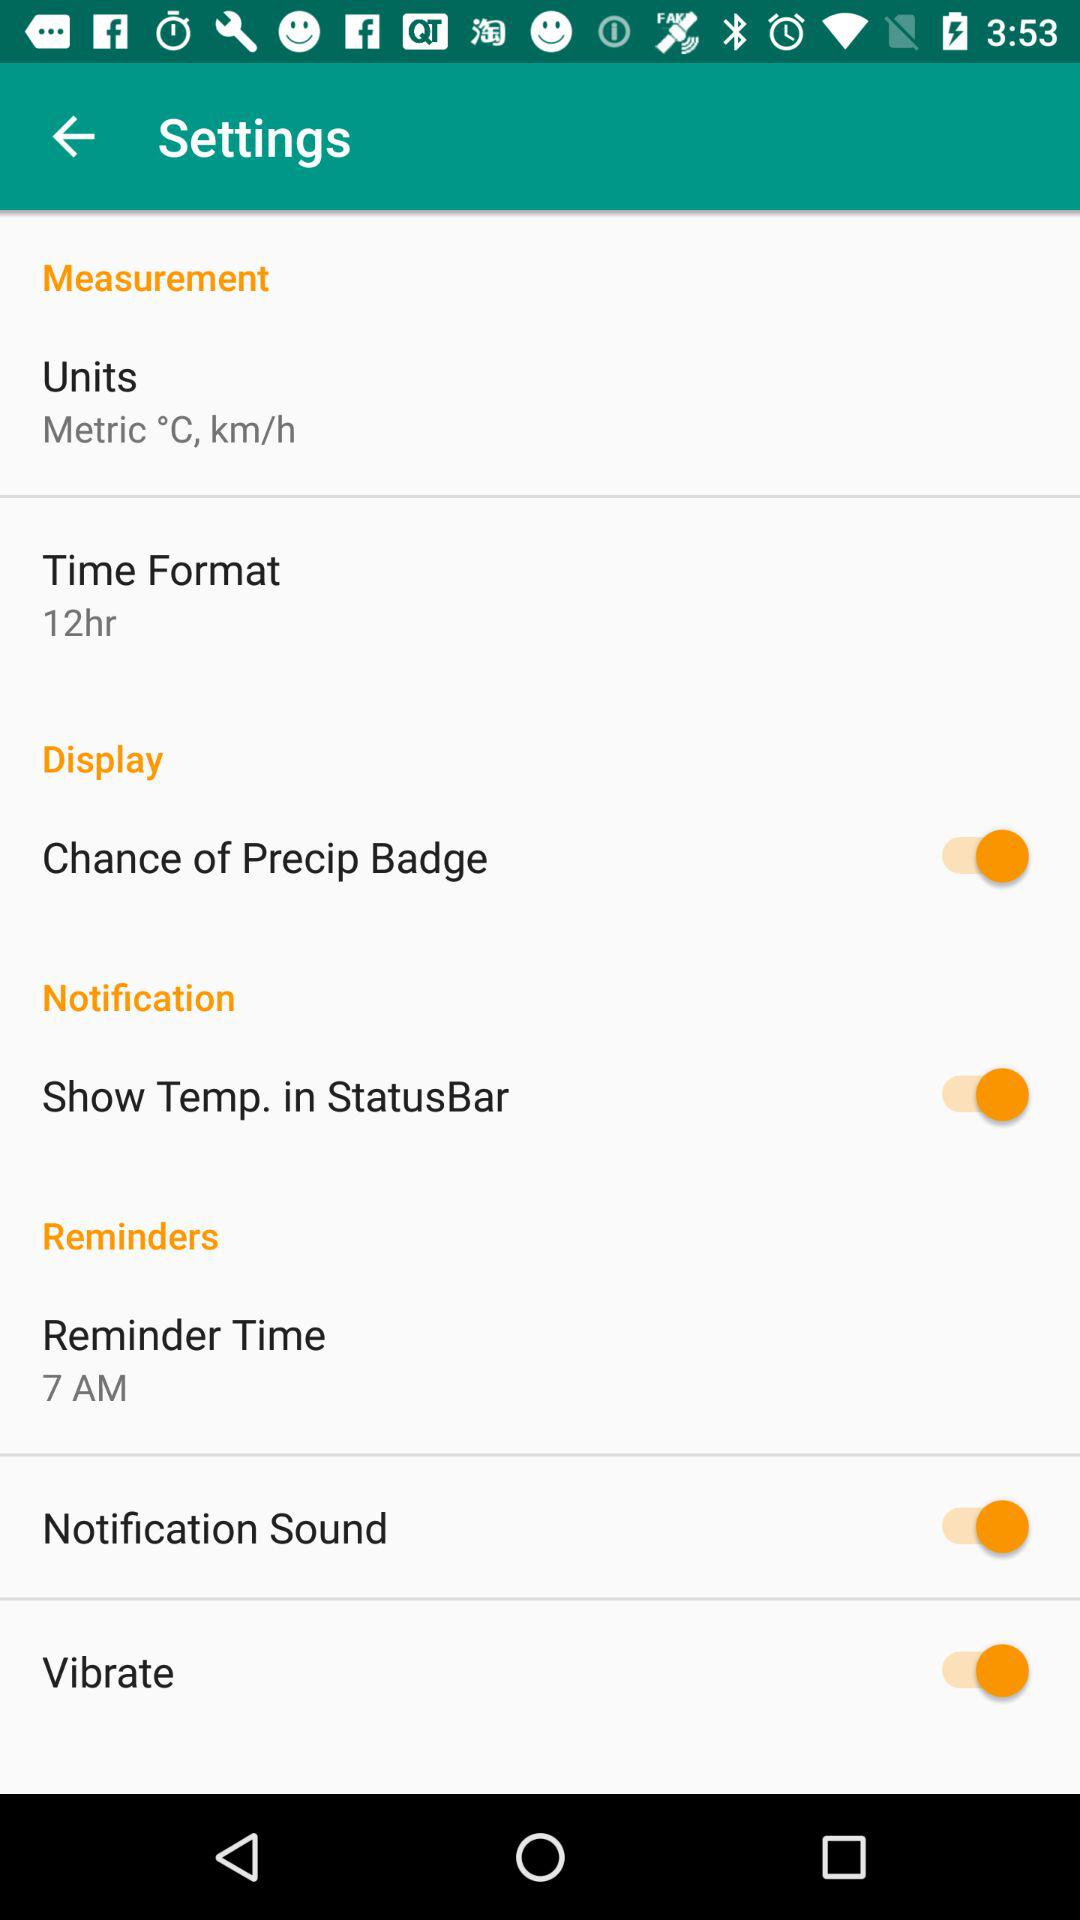What is the status of "Notification Sound"? The status is "on". 